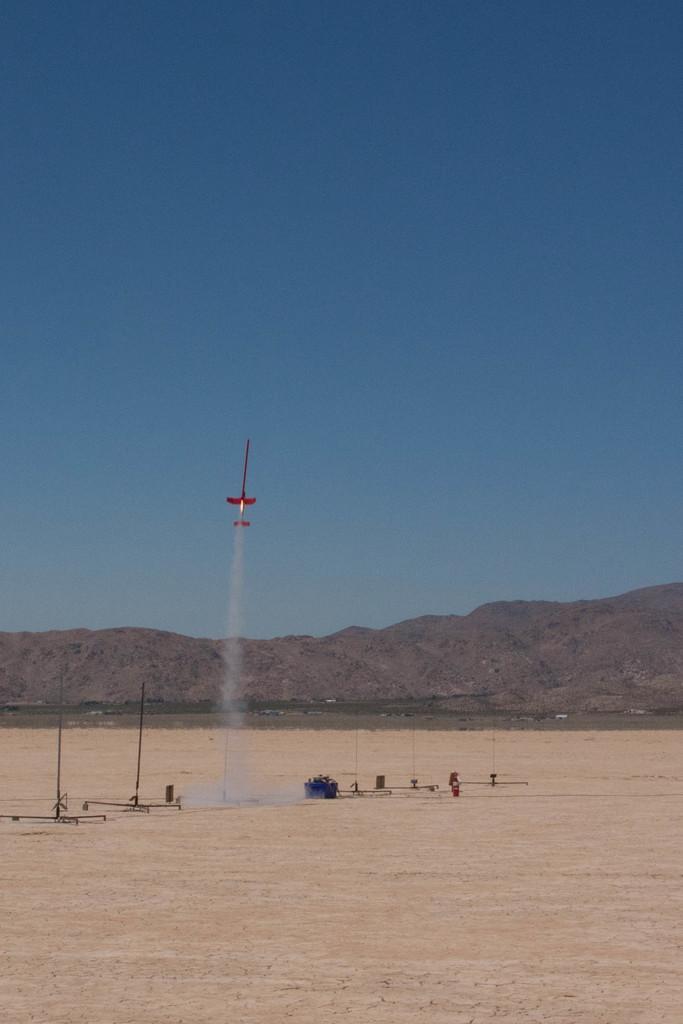How would you summarize this image in a sentence or two? In this image we can see poles on the ground. Here we can see an object is flying in the air and here we can see the smoke. In the background, we can see the hills and the blue color sky. 